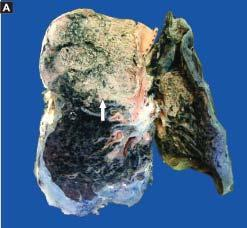does the basement membrane show grey-brown, firm area of consolidation affecting a lobe?
Answer the question using a single word or phrase. No 